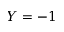Convert formula to latex. <formula><loc_0><loc_0><loc_500><loc_500>Y = - 1</formula> 